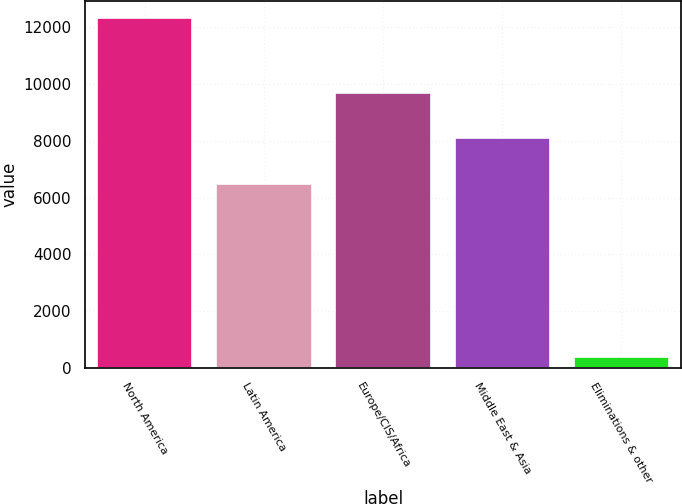<chart> <loc_0><loc_0><loc_500><loc_500><bar_chart><fcel>North America<fcel>Latin America<fcel>Europe/CIS/Africa<fcel>Middle East & Asia<fcel>Eliminations & other<nl><fcel>12323<fcel>6467<fcel>9676<fcel>8102<fcel>391<nl></chart> 